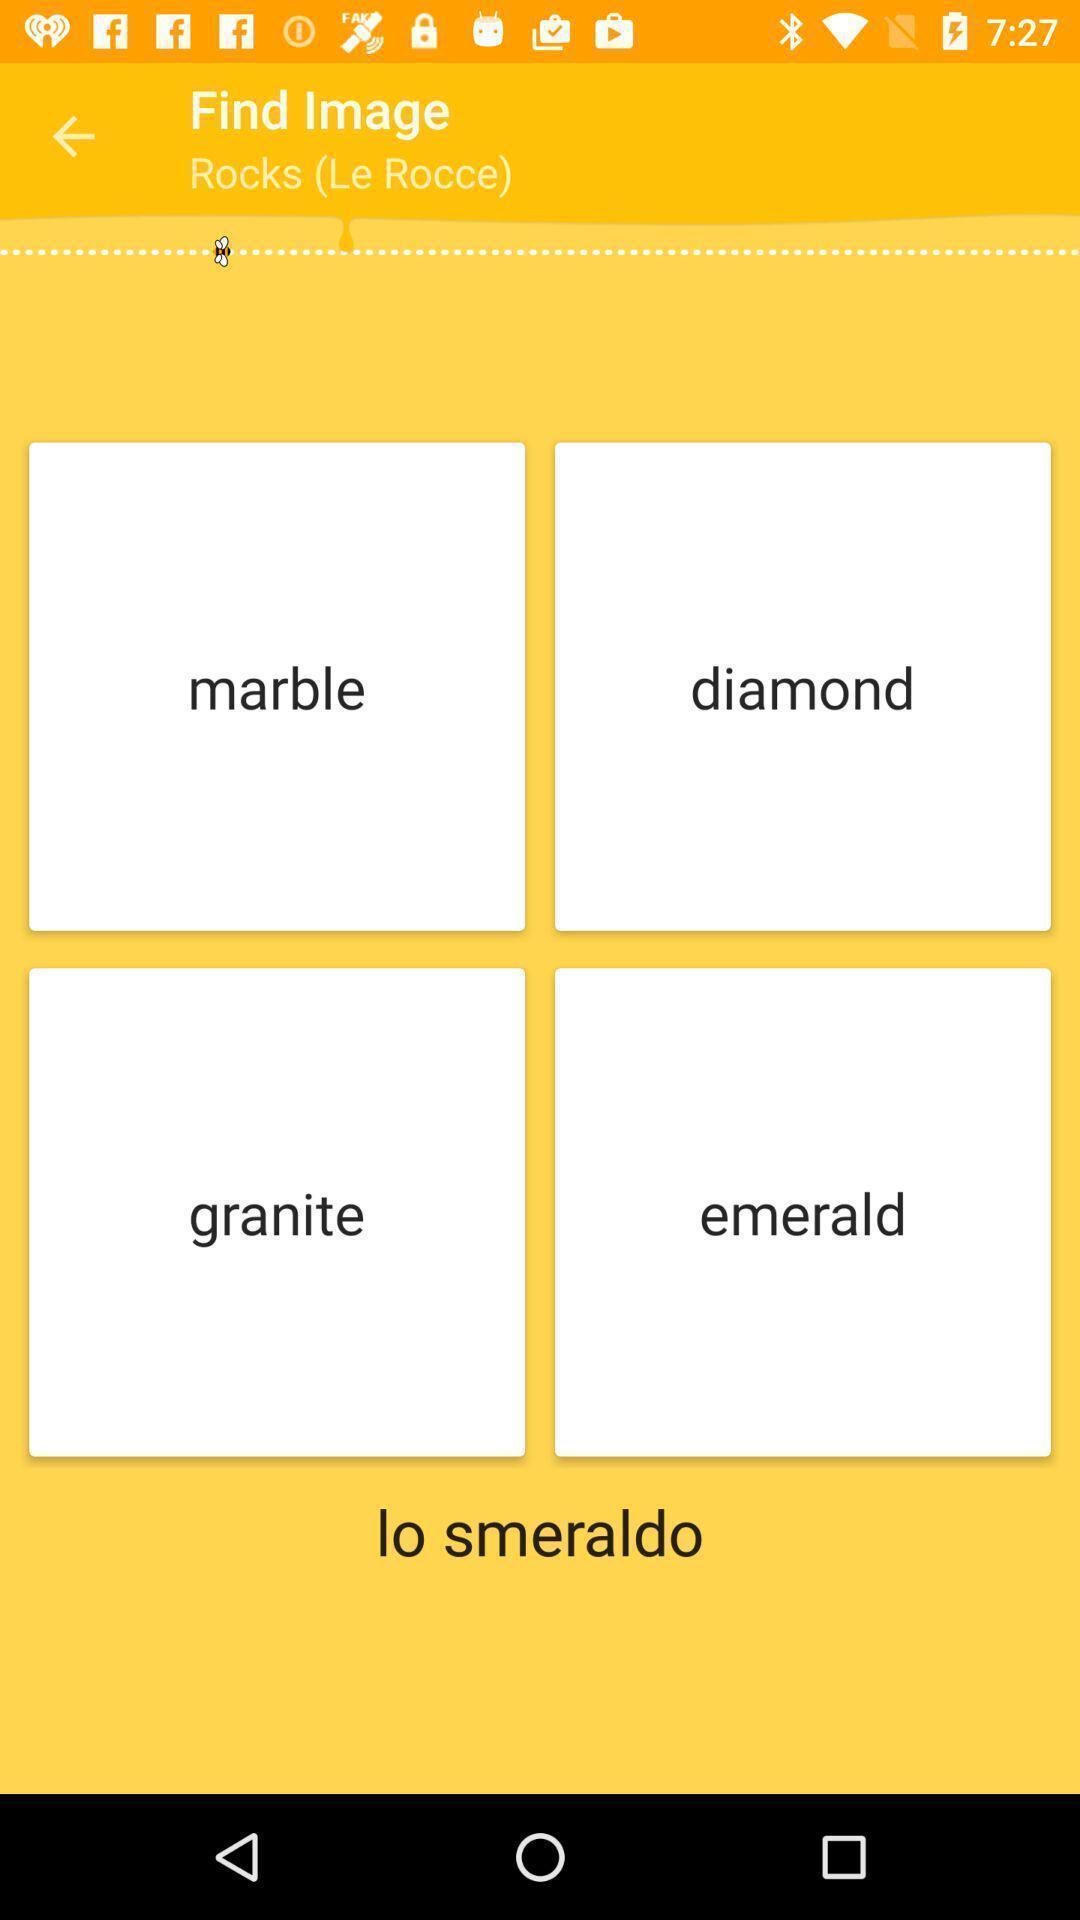Summarize the main components in this picture. Page displaying the multiple find image. 